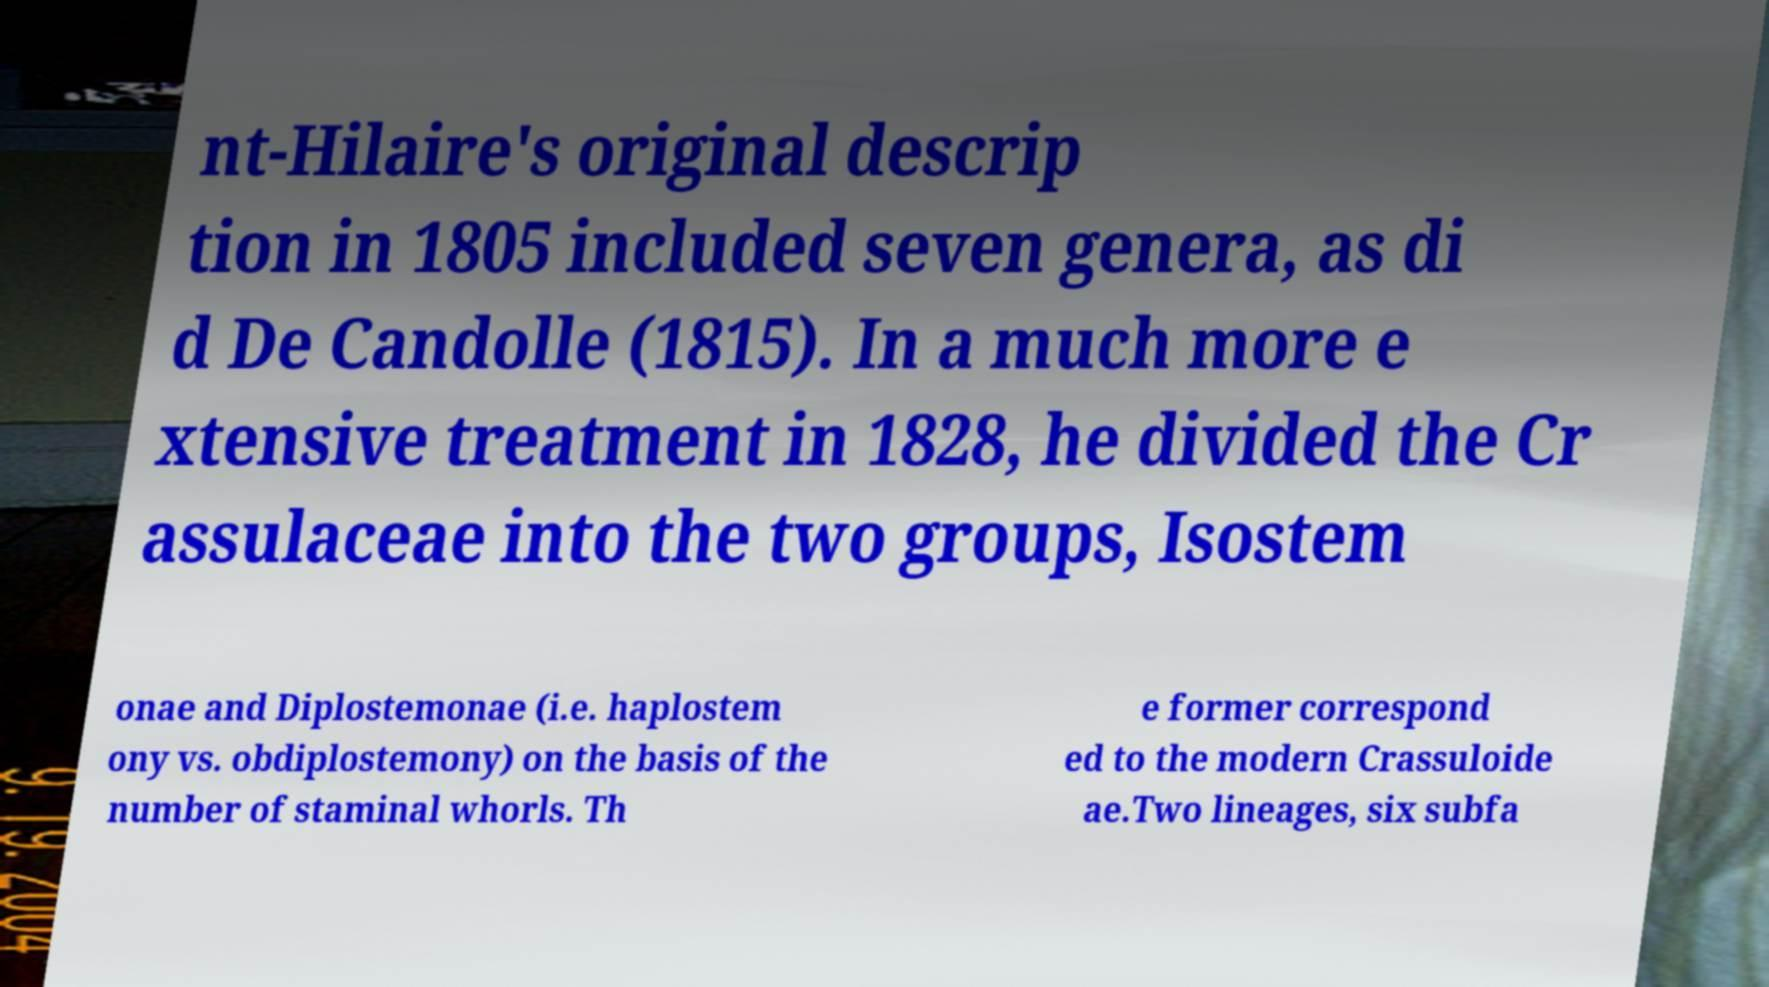There's text embedded in this image that I need extracted. Can you transcribe it verbatim? nt-Hilaire's original descrip tion in 1805 included seven genera, as di d De Candolle (1815). In a much more e xtensive treatment in 1828, he divided the Cr assulaceae into the two groups, Isostem onae and Diplostemonae (i.e. haplostem ony vs. obdiplostemony) on the basis of the number of staminal whorls. Th e former correspond ed to the modern Crassuloide ae.Two lineages, six subfa 